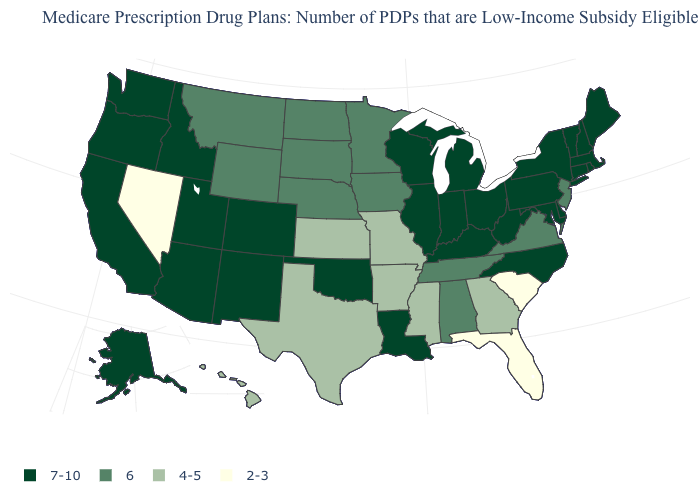What is the value of North Dakota?
Quick response, please. 6. How many symbols are there in the legend?
Give a very brief answer. 4. What is the value of Rhode Island?
Give a very brief answer. 7-10. Among the states that border Florida , which have the lowest value?
Keep it brief. Georgia. Does Georgia have the lowest value in the South?
Answer briefly. No. How many symbols are there in the legend?
Be succinct. 4. What is the value of Wyoming?
Be succinct. 6. What is the value of Iowa?
Write a very short answer. 6. What is the lowest value in the USA?
Concise answer only. 2-3. Name the states that have a value in the range 4-5?
Quick response, please. Arkansas, Georgia, Hawaii, Kansas, Mississippi, Missouri, Texas. Which states have the lowest value in the MidWest?
Write a very short answer. Kansas, Missouri. Among the states that border Maine , which have the lowest value?
Write a very short answer. New Hampshire. Name the states that have a value in the range 2-3?
Be succinct. Florida, Nevada, South Carolina. Does Wisconsin have the highest value in the USA?
Give a very brief answer. Yes. 